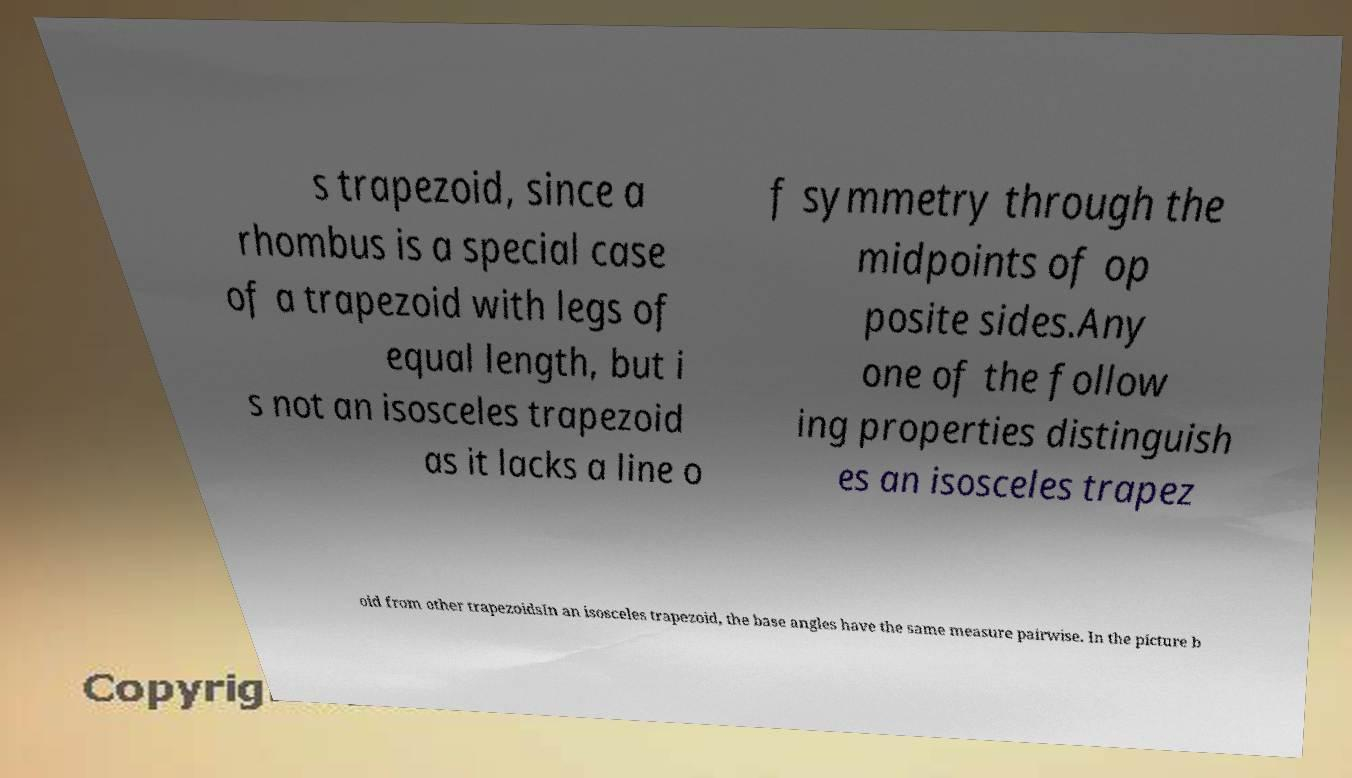Please identify and transcribe the text found in this image. s trapezoid, since a rhombus is a special case of a trapezoid with legs of equal length, but i s not an isosceles trapezoid as it lacks a line o f symmetry through the midpoints of op posite sides.Any one of the follow ing properties distinguish es an isosceles trapez oid from other trapezoidsIn an isosceles trapezoid, the base angles have the same measure pairwise. In the picture b 